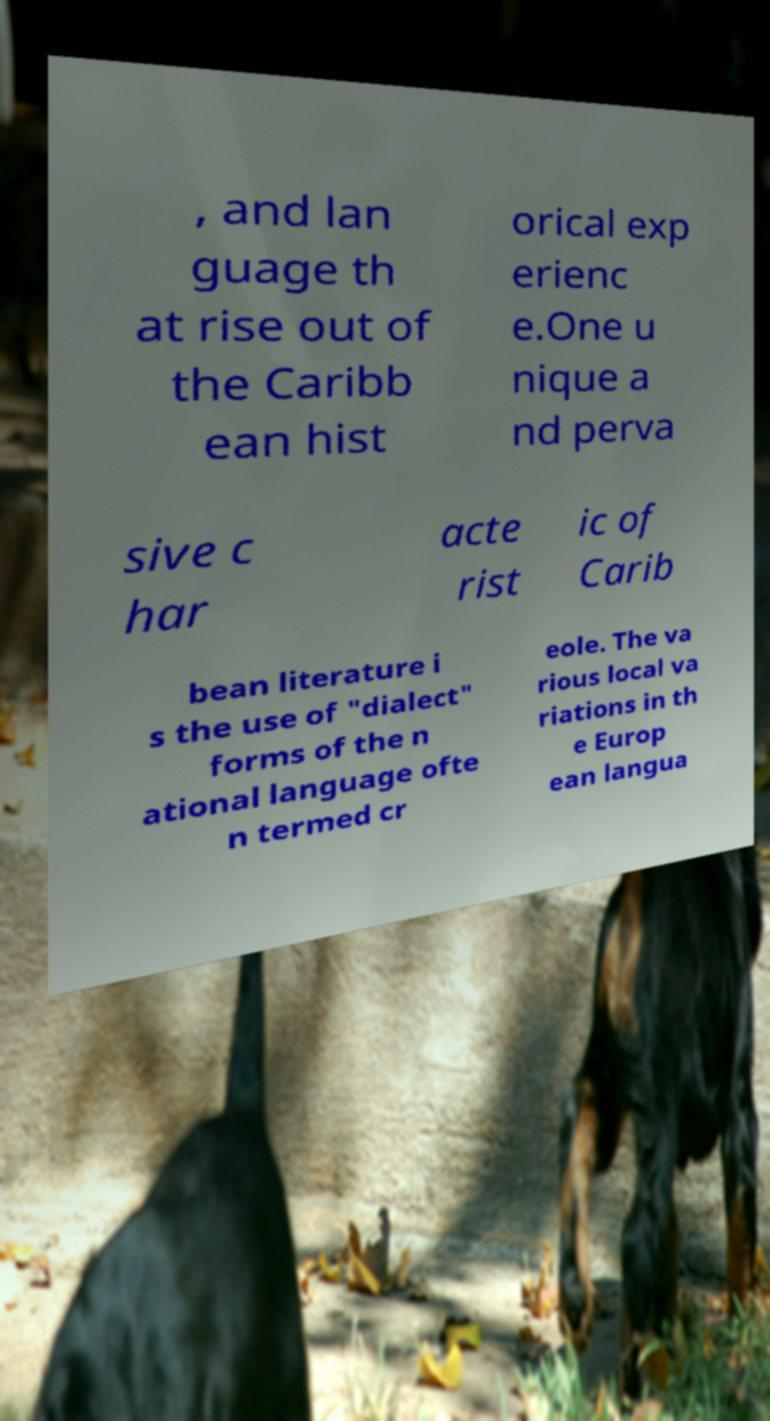Can you accurately transcribe the text from the provided image for me? , and lan guage th at rise out of the Caribb ean hist orical exp erienc e.One u nique a nd perva sive c har acte rist ic of Carib bean literature i s the use of "dialect" forms of the n ational language ofte n termed cr eole. The va rious local va riations in th e Europ ean langua 